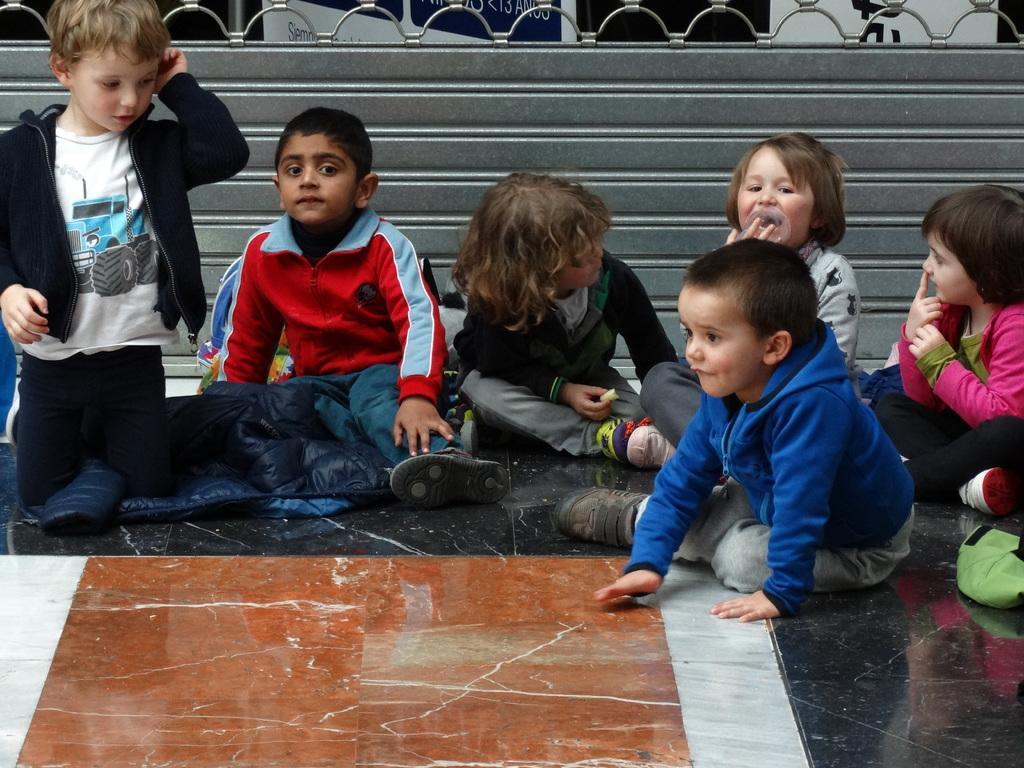Please provide a concise description of this image. In the image we can see there are six children sitting, they are wearing clothes and shoes. Here we can see the marble floor and a fence. 